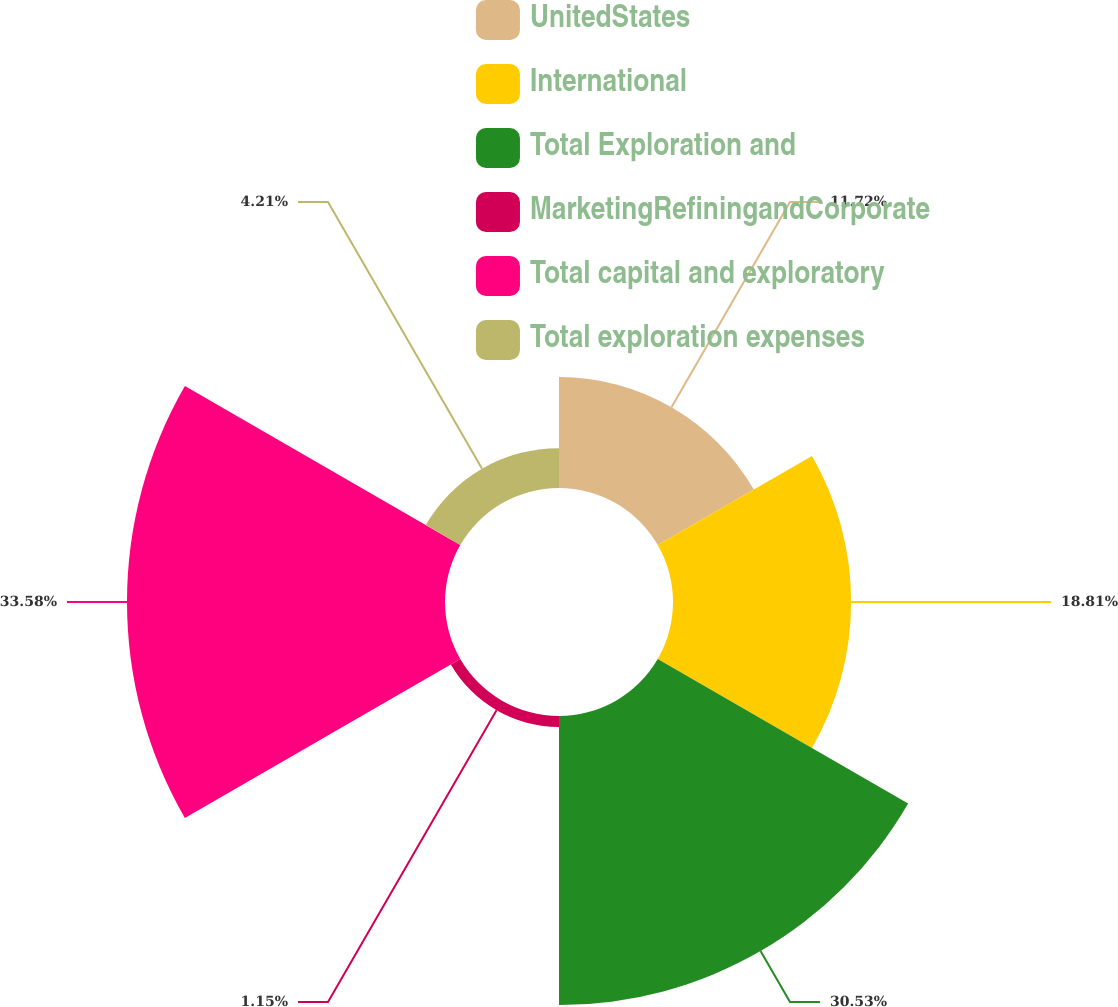<chart> <loc_0><loc_0><loc_500><loc_500><pie_chart><fcel>UnitedStates<fcel>International<fcel>Total Exploration and<fcel>MarketingRefiningandCorporate<fcel>Total capital and exploratory<fcel>Total exploration expenses<nl><fcel>11.72%<fcel>18.81%<fcel>30.53%<fcel>1.15%<fcel>33.58%<fcel>4.21%<nl></chart> 